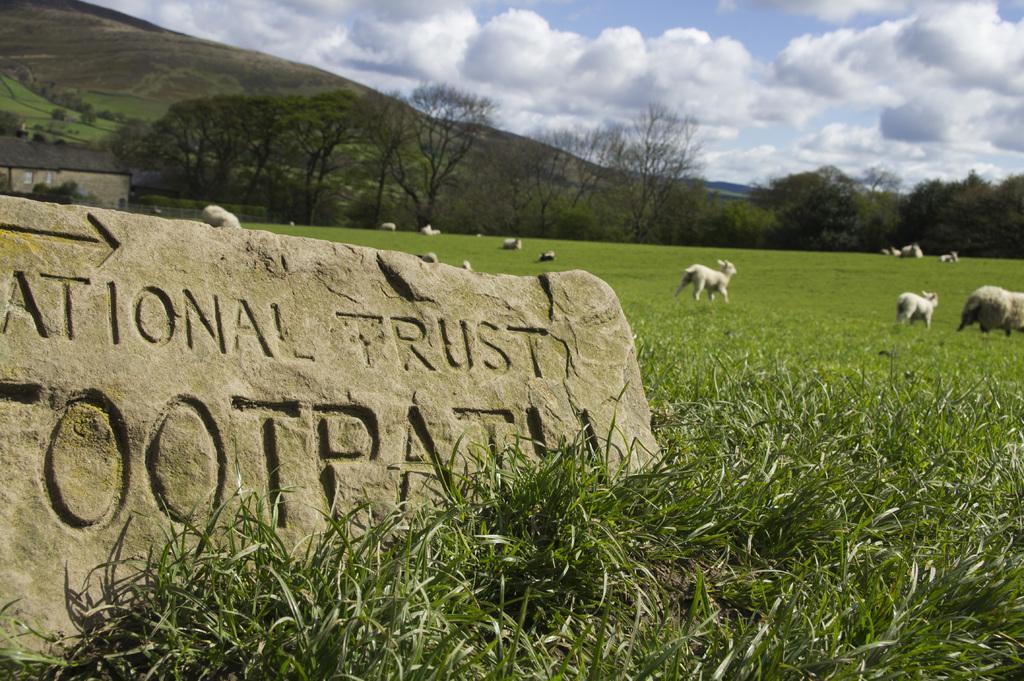Can you describe this image briefly? In this image few animals are on the grassland. Left side there is a stone having some text carved on it. Background there are few trees. Behind there is a hill. Top of the image there is sky with some clouds. 